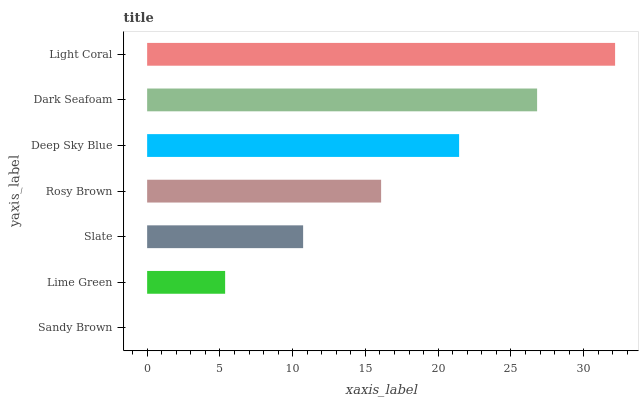Is Sandy Brown the minimum?
Answer yes or no. Yes. Is Light Coral the maximum?
Answer yes or no. Yes. Is Lime Green the minimum?
Answer yes or no. No. Is Lime Green the maximum?
Answer yes or no. No. Is Lime Green greater than Sandy Brown?
Answer yes or no. Yes. Is Sandy Brown less than Lime Green?
Answer yes or no. Yes. Is Sandy Brown greater than Lime Green?
Answer yes or no. No. Is Lime Green less than Sandy Brown?
Answer yes or no. No. Is Rosy Brown the high median?
Answer yes or no. Yes. Is Rosy Brown the low median?
Answer yes or no. Yes. Is Sandy Brown the high median?
Answer yes or no. No. Is Deep Sky Blue the low median?
Answer yes or no. No. 